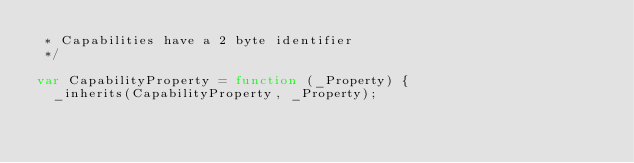<code> <loc_0><loc_0><loc_500><loc_500><_JavaScript_> * Capabilities have a 2 byte identifier
 */

var CapabilityProperty = function (_Property) {
  _inherits(CapabilityProperty, _Property);
</code> 